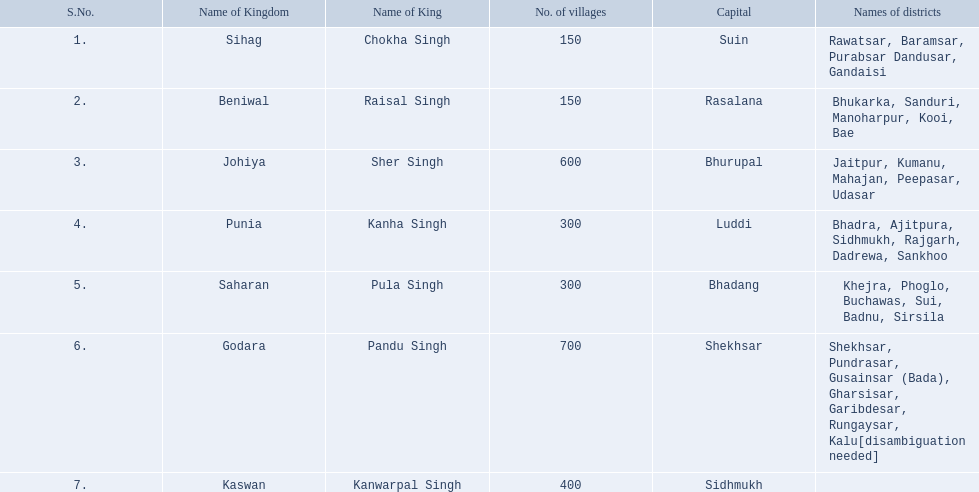In which kingdom were there the fewest villages, taking into account sihag? Beniwal. In which kingdom were there the most villages? Godara. Which village had an equal number of villages as godara, ranking second in the most villages category? Johiya. 